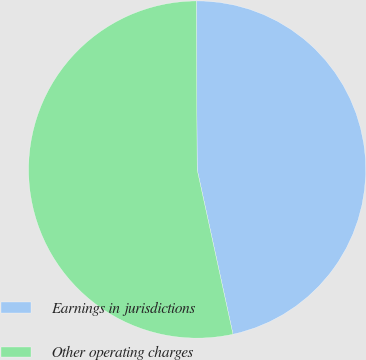<chart> <loc_0><loc_0><loc_500><loc_500><pie_chart><fcel>Earnings in jurisdictions<fcel>Other operating charges<nl><fcel>46.67%<fcel>53.33%<nl></chart> 